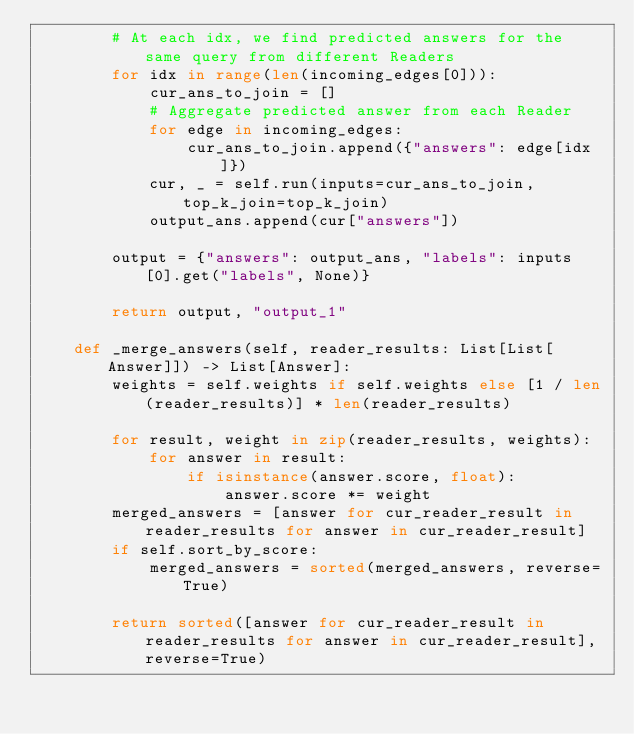Convert code to text. <code><loc_0><loc_0><loc_500><loc_500><_Python_>        # At each idx, we find predicted answers for the same query from different Readers
        for idx in range(len(incoming_edges[0])):
            cur_ans_to_join = []
            # Aggregate predicted answer from each Reader
            for edge in incoming_edges:
                cur_ans_to_join.append({"answers": edge[idx]})
            cur, _ = self.run(inputs=cur_ans_to_join, top_k_join=top_k_join)
            output_ans.append(cur["answers"])

        output = {"answers": output_ans, "labels": inputs[0].get("labels", None)}

        return output, "output_1"

    def _merge_answers(self, reader_results: List[List[Answer]]) -> List[Answer]:
        weights = self.weights if self.weights else [1 / len(reader_results)] * len(reader_results)

        for result, weight in zip(reader_results, weights):
            for answer in result:
                if isinstance(answer.score, float):
                    answer.score *= weight
        merged_answers = [answer for cur_reader_result in reader_results for answer in cur_reader_result]
        if self.sort_by_score:
            merged_answers = sorted(merged_answers, reverse=True)

        return sorted([answer for cur_reader_result in reader_results for answer in cur_reader_result], reverse=True)
</code> 